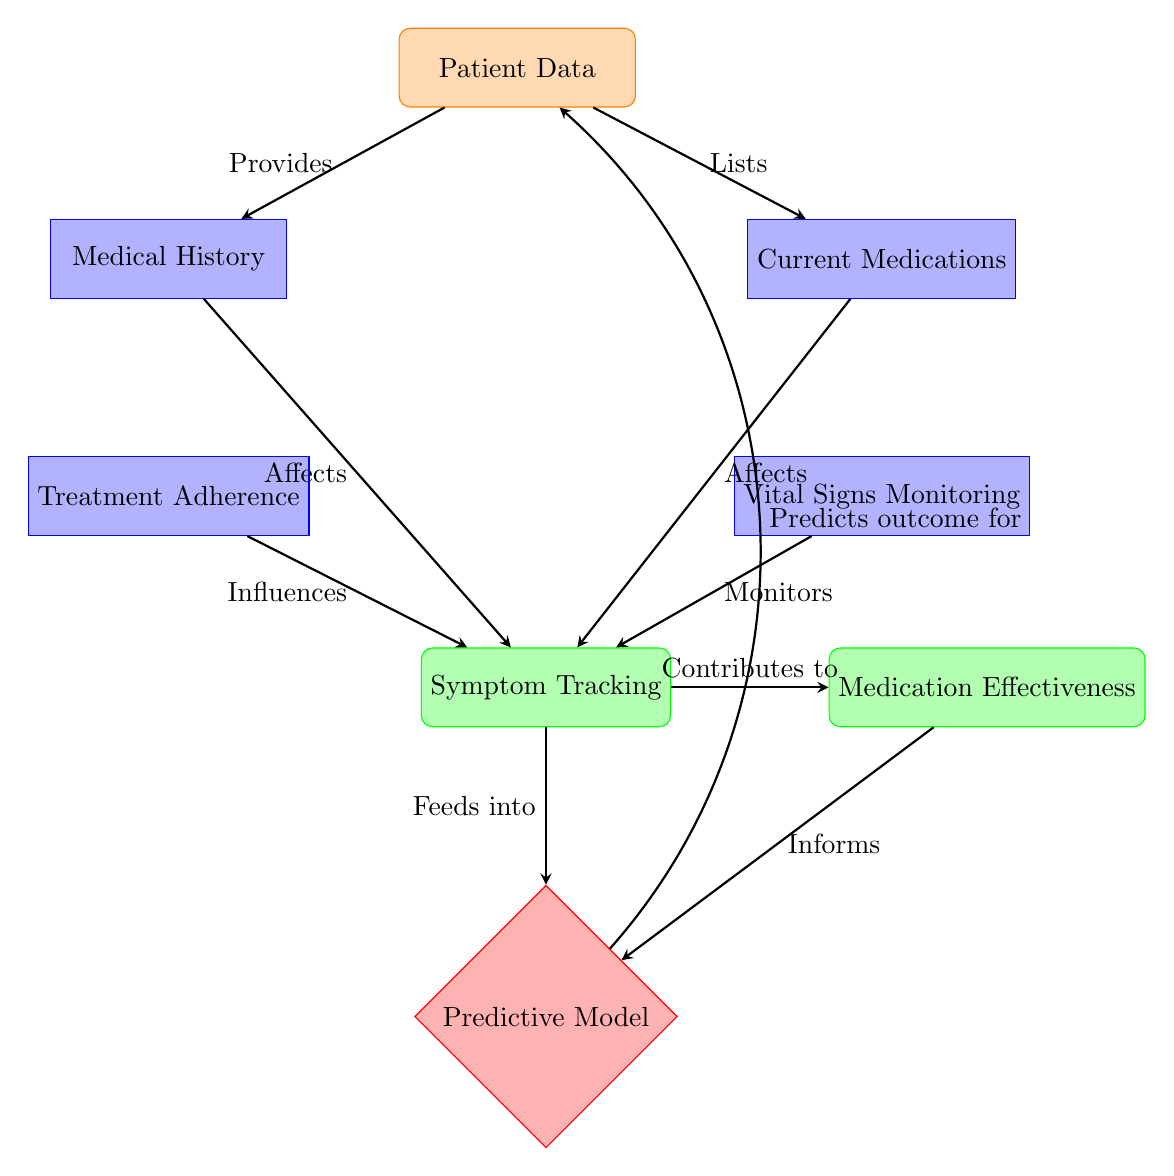What's the first input node in the diagram? The first input node in the diagram is labeled "Patient Data." It is located at the top of the diagram and serves as the source of the information that drives the process.
Answer: Patient Data How many process nodes are in the diagram? There are four process nodes in the diagram: "Medical History," "Current Medications," "Treatment Adherence," and "Vital Signs Monitoring." These nodes are shown below the input node and contribute to symptom tracking.
Answer: 4 What does the arrow from "Patient Data" to "Medical History" indicate? The arrow from "Patient Data" to "Medical History" indicates that patient data provides information that is relevant for assessing the medical history of the patient.
Answer: Provides Which nodes contribute to "Medication Effectiveness"? The node "Symptom Tracking" contributes to "Medication Effectiveness." The arrow shows a direct contribution of the tracking of symptoms to the effectiveness of medications over time.
Answer: Symptom Tracking What is the function of the "Predictive Model" node? The "Predictive Model" node has a function to predict outcomes for the patient based on various inputs, including symptoms and medication effectiveness. This is indicated by the bent arrow pointing from "model" back to "patient."
Answer: Predicts outcome for What factors influence symptoms as shown in the diagram? Symptoms are influenced by three factors as shown in the diagram: "Medical History," "Current Medications," and "Treatment Adherence." Each of these process nodes sends an arrow towards "Symptom Tracking," indicating their influence.
Answer: Medical History, Current Medications, Treatment Adherence How does "Vital Signs Monitoring" relate to "Symptom Tracking"? "Vital Signs Monitoring" is linked to "Symptom Tracking" through a flow arrow that indicates it monitors the vital signs, which contribute to tracking symptoms. This implies that monitoring can affect symptom assessment.
Answer: Monitors What does the relationship between "Medication Effectiveness" and "Predictive Model" imply? The relationship indicates that the effectiveness of the medication informs the "Predictive Model," suggesting that the results from the medication's effectiveness are used to refine predictions about patient outcomes.
Answer: Informs Which node marks the transition from outputs back to the input category? The "Predictive Model" node marks the transition from outputs back to the input category, as it predicts outcomes for the patient based on the information processed from prior nodes. This completes the cycle of data from input to prediction.
Answer: Predictive Model 